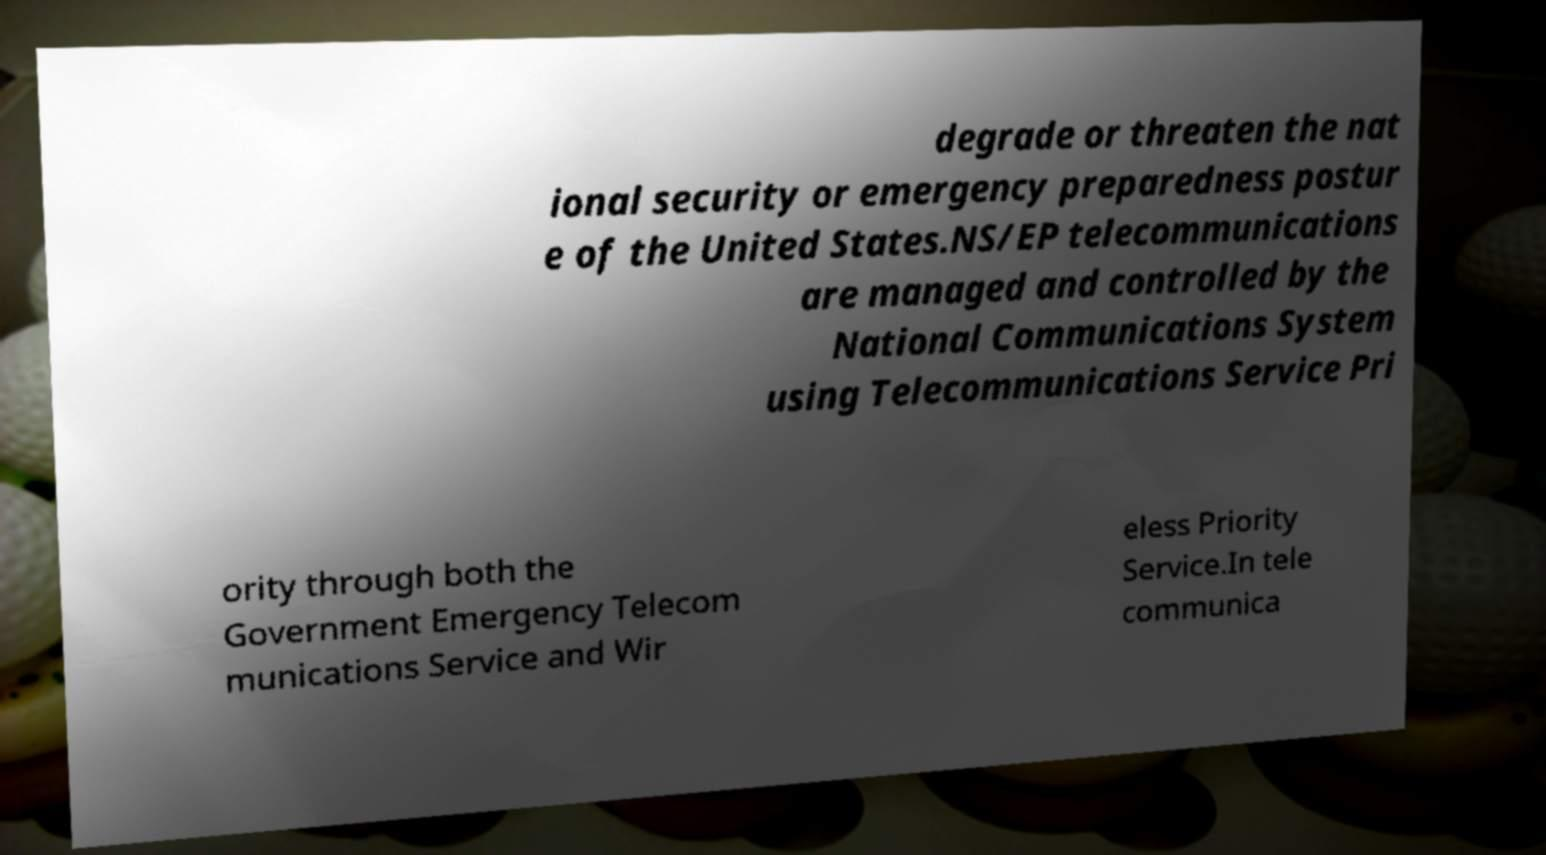Could you assist in decoding the text presented in this image and type it out clearly? degrade or threaten the nat ional security or emergency preparedness postur e of the United States.NS/EP telecommunications are managed and controlled by the National Communications System using Telecommunications Service Pri ority through both the Government Emergency Telecom munications Service and Wir eless Priority Service.In tele communica 